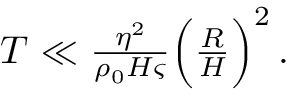<formula> <loc_0><loc_0><loc_500><loc_500>\begin{array} { r } { T \ll \frac { \eta ^ { 2 } } { \rho _ { 0 } H \varsigma } \left ( \frac { R } { H } \right ) ^ { 2 } \, . \ } \end{array}</formula> 